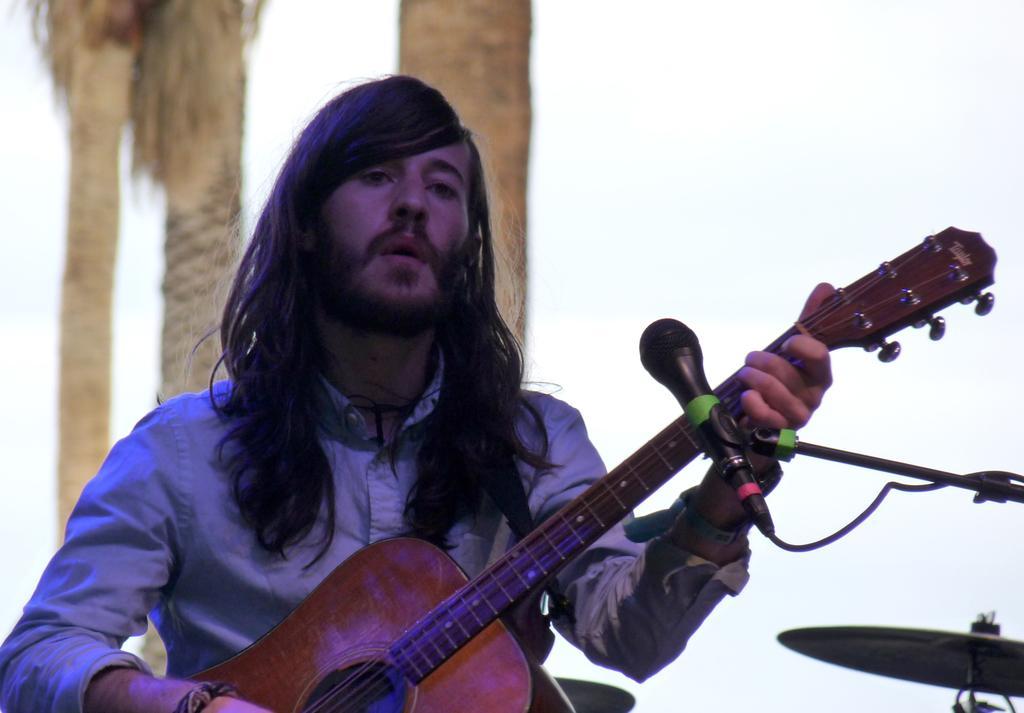Please provide a concise description of this image. On the background of a picture we can see branches of a tree. In Front of a picture we can see a man with a long hair sitting and playing a guitar infront of a mike. This is a cymbal, musical instrument. 